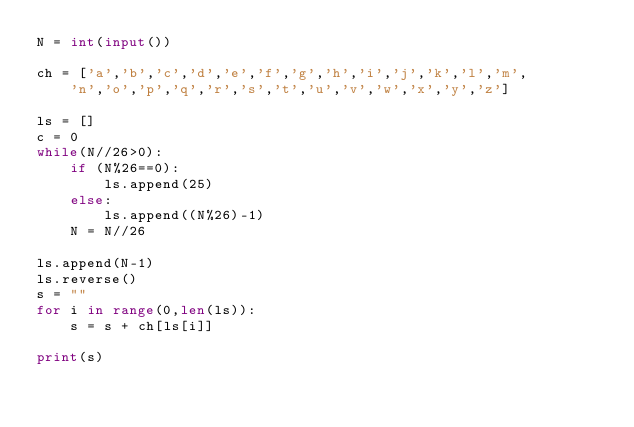Convert code to text. <code><loc_0><loc_0><loc_500><loc_500><_Python_>N = int(input())

ch = ['a','b','c','d','e','f','g','h','i','j','k','l','m',
    'n','o','p','q','r','s','t','u','v','w','x','y','z']

ls = []
c = 0
while(N//26>0):
    if (N%26==0):
        ls.append(25)
    else:
        ls.append((N%26)-1)
    N = N//26

ls.append(N-1)
ls.reverse()
s = ""
for i in range(0,len(ls)):
    s = s + ch[ls[i]]

print(s)

</code> 